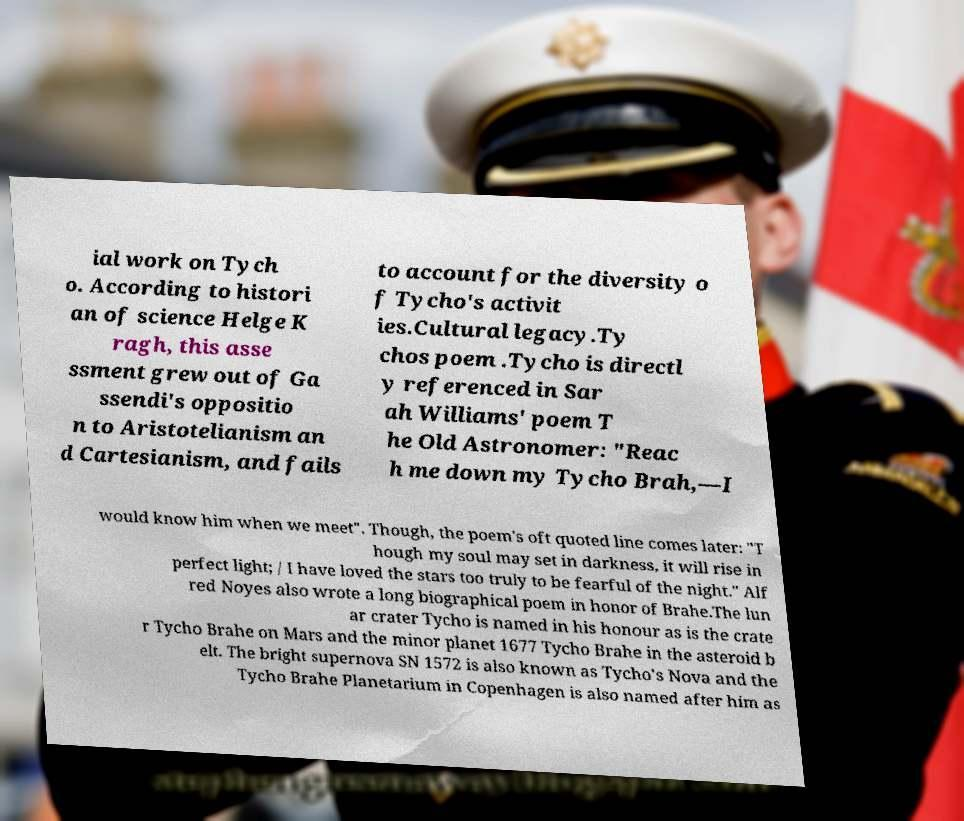Can you read and provide the text displayed in the image?This photo seems to have some interesting text. Can you extract and type it out for me? ial work on Tych o. According to histori an of science Helge K ragh, this asse ssment grew out of Ga ssendi's oppositio n to Aristotelianism an d Cartesianism, and fails to account for the diversity o f Tycho's activit ies.Cultural legacy.Ty chos poem .Tycho is directl y referenced in Sar ah Williams' poem T he Old Astronomer: "Reac h me down my Tycho Brah,—I would know him when we meet". Though, the poem's oft quoted line comes later: "T hough my soul may set in darkness, it will rise in perfect light; / I have loved the stars too truly to be fearful of the night." Alf red Noyes also wrote a long biographical poem in honor of Brahe.The lun ar crater Tycho is named in his honour as is the crate r Tycho Brahe on Mars and the minor planet 1677 Tycho Brahe in the asteroid b elt. The bright supernova SN 1572 is also known as Tycho's Nova and the Tycho Brahe Planetarium in Copenhagen is also named after him as 